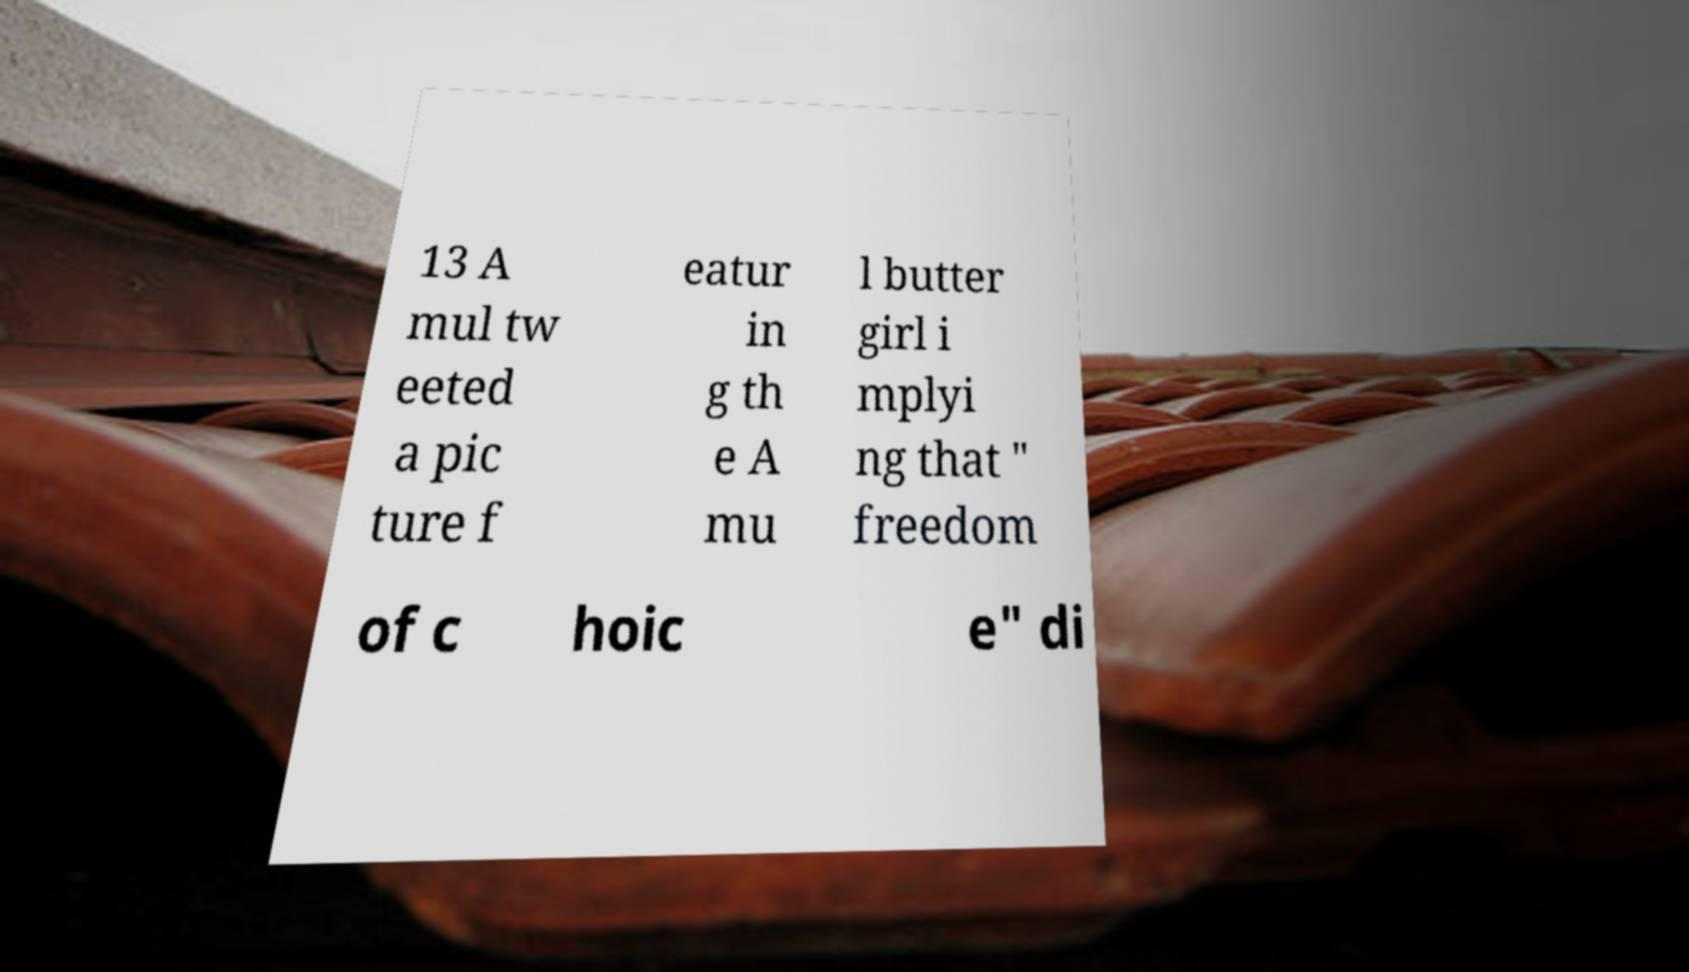Could you assist in decoding the text presented in this image and type it out clearly? 13 A mul tw eeted a pic ture f eatur in g th e A mu l butter girl i mplyi ng that " freedom of c hoic e" di 